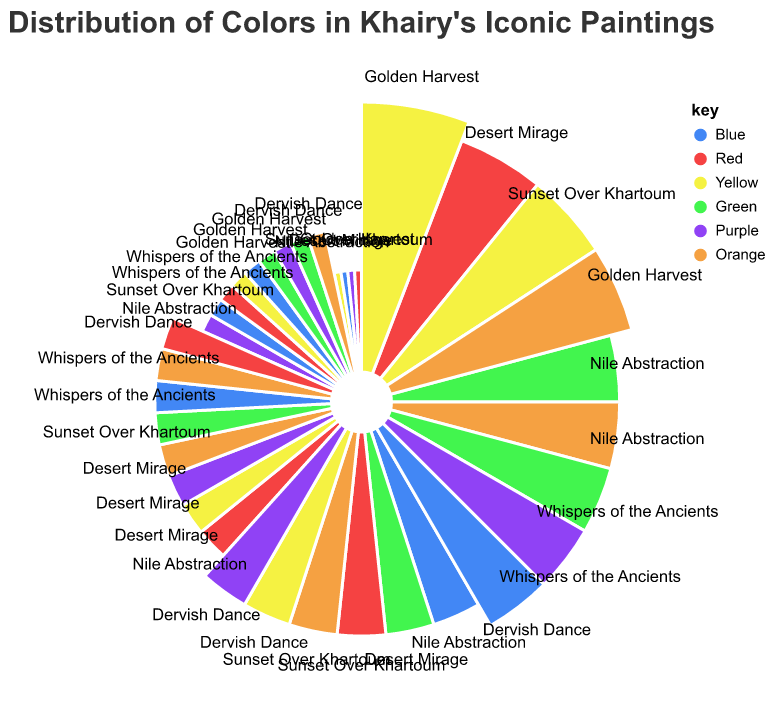What is the dominant color in the painting "Nile Abstraction"? By observing the segment sizes in the Polar Chart for "Nile Abstraction," we can see that both the colors Green and Orange have the largest segments. The values for both colors are tied at 25.
Answer: Green and Orange Which painting has the highest percentage of Yellow? By comparing the segments for Yellow across all the paintings, we can see that "Golden Harvest" has the largest Yellow segment with a value of 35.
Answer: Golden Harvest In the painting "Dervish Dance," which color is least used? Observing the segments of "Dervish Dance," the color Orange has the smallest segment with a value of 10.
Answer: Orange What is the total combined percentage of the color Blue in "Sunset Over Khartoum" and "Whispers of the Ancients"? The Blue segments in "Sunset Over Khartoum" and "Whispers of the Ancients" are 10 and 15, respectively. Adding these together gives 25.
Answer: 25 Which painting has the most balanced use of all six colors? By inspecting the Polar Chart, we see that "Whispers of the Ancients" shows relatively equal segment sizes for all the colors, meaning it has a more balanced distribution.
Answer: Whispers of the Ancients Is the segment size for the color Red larger in "Desert Mirage" or "Dervish Dance"? Comparing the size of Red segments in "Desert Mirage" and "Dervish Dance" reveals that "Desert Mirage" has a larger Red segment (30) than "Dervish Dance" (15).
Answer: Desert Mirage How many paintings have a higher value of Green than Blue? By comparing the Green and Blue segments for each painting: "Nile Abstraction," "Desert Mirage," "Whispers of the Ancients," and "Sunset Over Khartoum" all have higher Green values than Blue, making a total of four paintings.
Answer: 4 Which colors are used equally in the painting "Nile Abstraction"? In the "Nile Abstraction," the colors Green and Orange both have a value of 25, indicating they are used equally.
Answer: Green and Orange What is the difference in percentage between the use of Red and Purple in "Golden Harvest"? For "Golden Harvest," the segment sizes are 5 for Red and 10 for Purple. The difference is 10 - 5 = 5.
Answer: 5 Considering all paintings, which color has the highest individual usage value, and what is the name of the painting? Comparing individual segments, the Yellow segment in "Golden Harvest" is the highest with a value of 35.
Answer: Yellow in Golden Harvest 